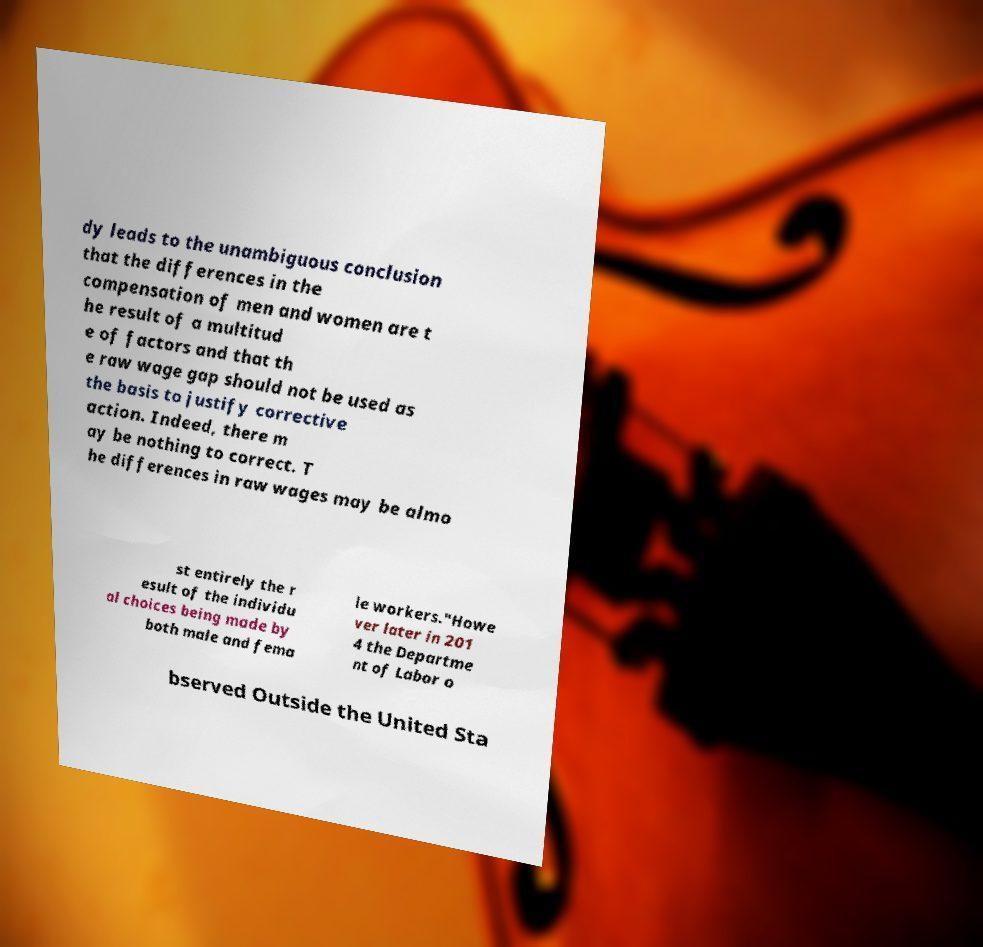For documentation purposes, I need the text within this image transcribed. Could you provide that? dy leads to the unambiguous conclusion that the differences in the compensation of men and women are t he result of a multitud e of factors and that th e raw wage gap should not be used as the basis to justify corrective action. Indeed, there m ay be nothing to correct. T he differences in raw wages may be almo st entirely the r esult of the individu al choices being made by both male and fema le workers."Howe ver later in 201 4 the Departme nt of Labor o bserved Outside the United Sta 